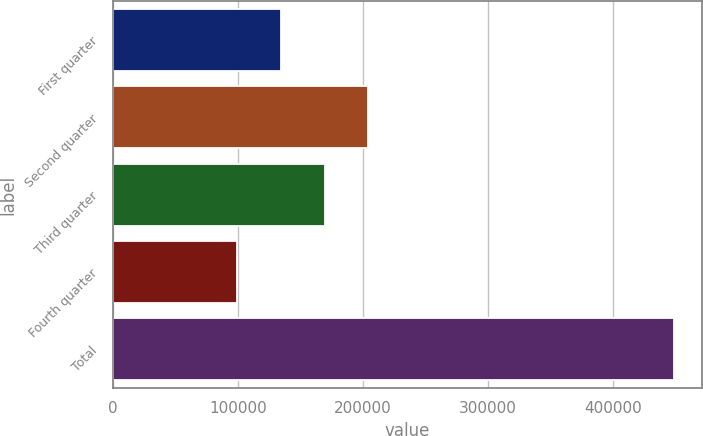<chart> <loc_0><loc_0><loc_500><loc_500><bar_chart><fcel>First quarter<fcel>Second quarter<fcel>Third quarter<fcel>Fourth quarter<fcel>Total<nl><fcel>134170<fcel>204051<fcel>169110<fcel>99229<fcel>448636<nl></chart> 